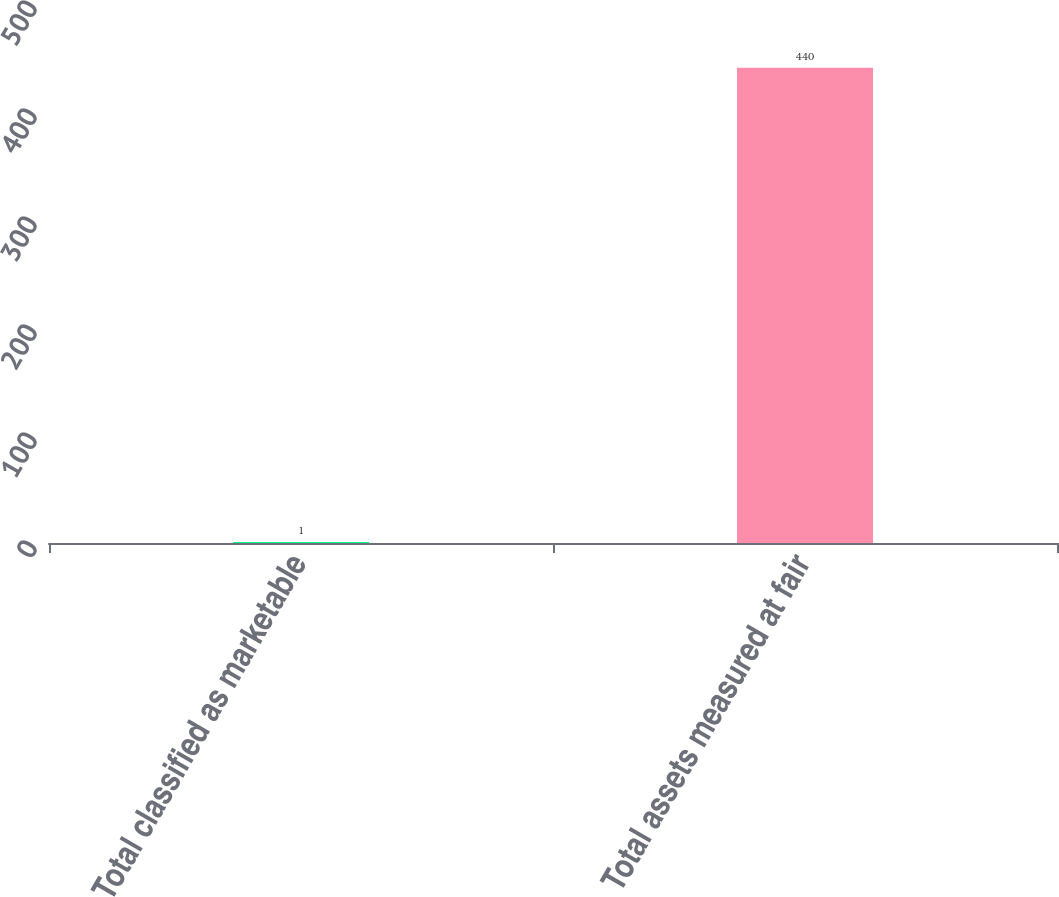<chart> <loc_0><loc_0><loc_500><loc_500><bar_chart><fcel>Total classified as marketable<fcel>Total assets measured at fair<nl><fcel>1<fcel>440<nl></chart> 